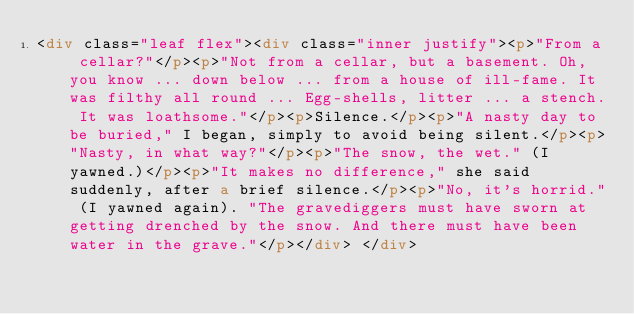<code> <loc_0><loc_0><loc_500><loc_500><_HTML_><div class="leaf flex"><div class="inner justify"><p>"From a cellar?"</p><p>"Not from a cellar, but a basement. Oh, you know ... down below ... from a house of ill-fame. It was filthy all round ... Egg-shells, litter ... a stench. It was loathsome."</p><p>Silence.</p><p>"A nasty day to be buried," I began, simply to avoid being silent.</p><p>"Nasty, in what way?"</p><p>"The snow, the wet." (I yawned.)</p><p>"It makes no difference," she said suddenly, after a brief silence.</p><p>"No, it's horrid." (I yawned again). "The gravediggers must have sworn at getting drenched by the snow. And there must have been water in the grave."</p></div> </div></code> 